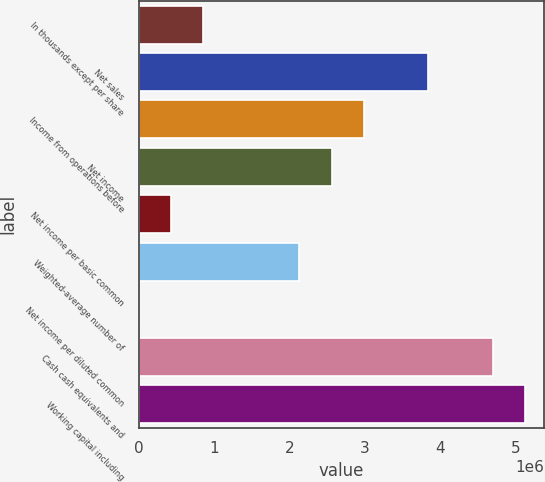<chart> <loc_0><loc_0><loc_500><loc_500><bar_chart><fcel>In thousands except per share<fcel>Net sales<fcel>Income from operations before<fcel>Net income<fcel>Net income per basic common<fcel>Weighted-average number of<fcel>Net income per diluted common<fcel>Cash cash equivalents and<fcel>Working capital including<nl><fcel>853740<fcel>3.84181e+06<fcel>2.98808e+06<fcel>2.56121e+06<fcel>426873<fcel>2.13434e+06<fcel>5.65<fcel>4.69554e+06<fcel>5.12241e+06<nl></chart> 